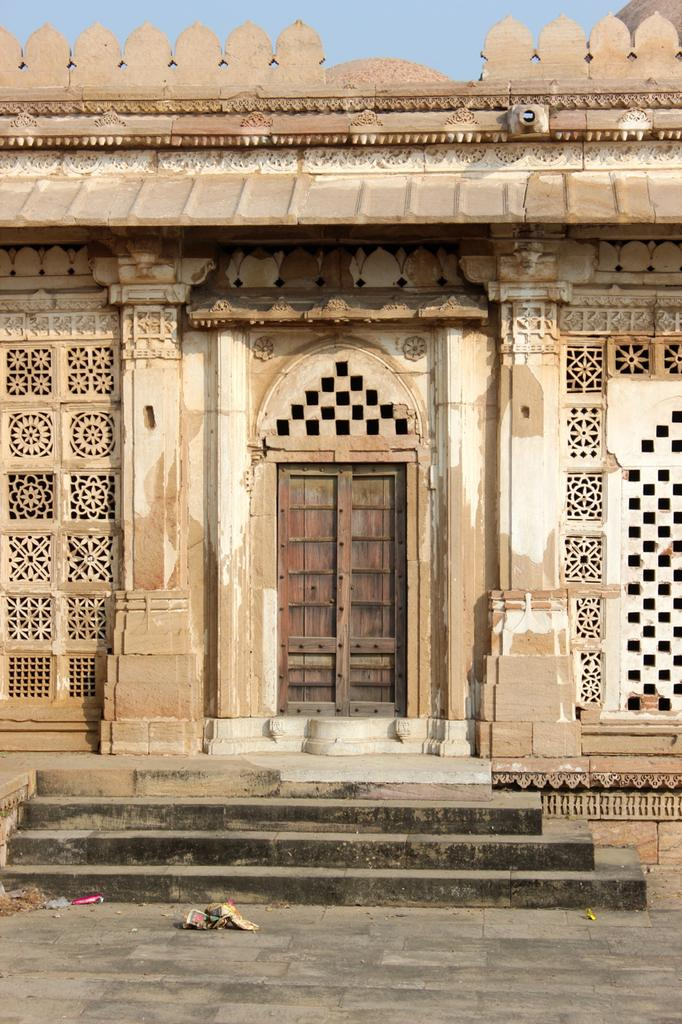What type of structure is present in the image? There is a building in the image. Can you describe a specific feature of the building? There is a door in the middle of the building. What is visible at the top of the image? The sky is visible at the top of the image. What architectural element can be seen at the bottom of the image? There are stairs at the bottom of the image. What type of haircut does the uncle have in the image? There is no uncle or haircut present in the image. Can you tell me what animals are visible at the zoo in the image? There is no zoo present in the image. 